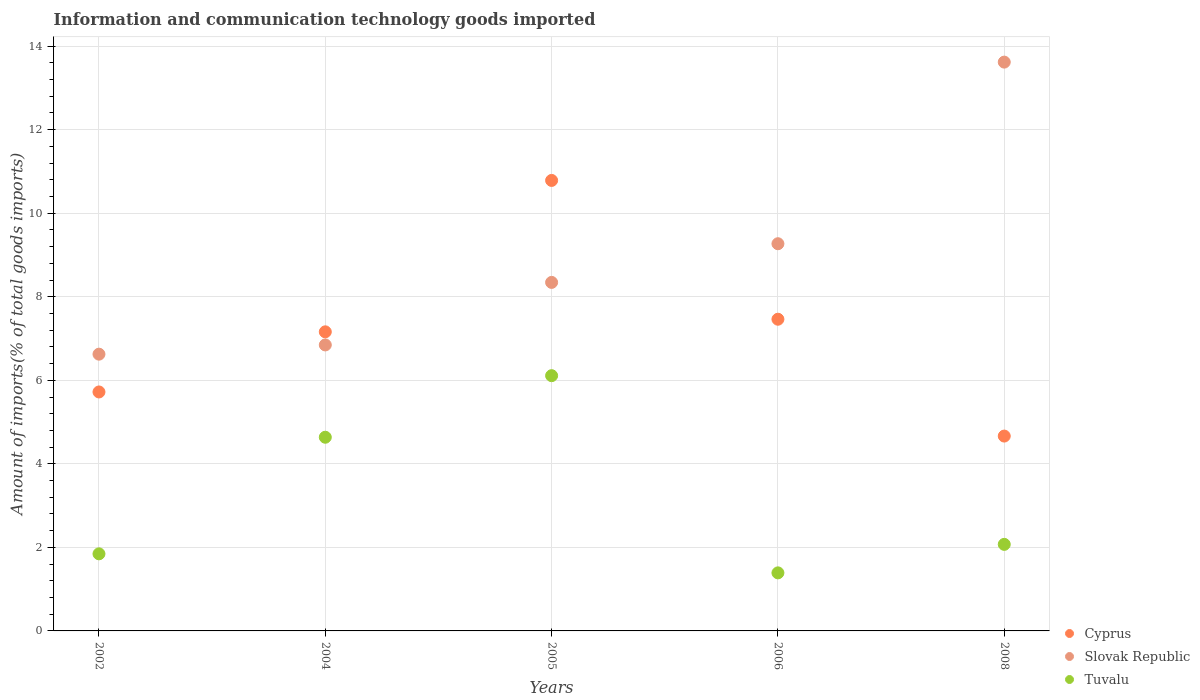How many different coloured dotlines are there?
Give a very brief answer. 3. Is the number of dotlines equal to the number of legend labels?
Keep it short and to the point. Yes. What is the amount of goods imported in Slovak Republic in 2004?
Offer a terse response. 6.85. Across all years, what is the maximum amount of goods imported in Cyprus?
Ensure brevity in your answer.  10.78. Across all years, what is the minimum amount of goods imported in Tuvalu?
Ensure brevity in your answer.  1.39. What is the total amount of goods imported in Cyprus in the graph?
Your answer should be compact. 35.79. What is the difference between the amount of goods imported in Tuvalu in 2005 and that in 2008?
Provide a succinct answer. 4.04. What is the difference between the amount of goods imported in Cyprus in 2005 and the amount of goods imported in Slovak Republic in 2008?
Offer a very short reply. -2.83. What is the average amount of goods imported in Slovak Republic per year?
Your answer should be compact. 8.94. In the year 2002, what is the difference between the amount of goods imported in Cyprus and amount of goods imported in Slovak Republic?
Offer a terse response. -0.9. In how many years, is the amount of goods imported in Tuvalu greater than 4 %?
Provide a short and direct response. 2. What is the ratio of the amount of goods imported in Tuvalu in 2002 to that in 2004?
Offer a terse response. 0.4. Is the difference between the amount of goods imported in Cyprus in 2004 and 2005 greater than the difference between the amount of goods imported in Slovak Republic in 2004 and 2005?
Keep it short and to the point. No. What is the difference between the highest and the second highest amount of goods imported in Tuvalu?
Provide a short and direct response. 1.47. What is the difference between the highest and the lowest amount of goods imported in Slovak Republic?
Your answer should be compact. 6.99. In how many years, is the amount of goods imported in Tuvalu greater than the average amount of goods imported in Tuvalu taken over all years?
Offer a very short reply. 2. Is it the case that in every year, the sum of the amount of goods imported in Cyprus and amount of goods imported in Tuvalu  is greater than the amount of goods imported in Slovak Republic?
Offer a terse response. No. Is the amount of goods imported in Slovak Republic strictly greater than the amount of goods imported in Tuvalu over the years?
Offer a terse response. Yes. Is the amount of goods imported in Cyprus strictly less than the amount of goods imported in Tuvalu over the years?
Ensure brevity in your answer.  No. How many dotlines are there?
Your answer should be very brief. 3. How many years are there in the graph?
Your answer should be compact. 5. What is the difference between two consecutive major ticks on the Y-axis?
Make the answer very short. 2. What is the title of the graph?
Provide a short and direct response. Information and communication technology goods imported. Does "Costa Rica" appear as one of the legend labels in the graph?
Give a very brief answer. No. What is the label or title of the Y-axis?
Keep it short and to the point. Amount of imports(% of total goods imports). What is the Amount of imports(% of total goods imports) of Cyprus in 2002?
Ensure brevity in your answer.  5.72. What is the Amount of imports(% of total goods imports) of Slovak Republic in 2002?
Give a very brief answer. 6.63. What is the Amount of imports(% of total goods imports) of Tuvalu in 2002?
Offer a terse response. 1.85. What is the Amount of imports(% of total goods imports) of Cyprus in 2004?
Give a very brief answer. 7.16. What is the Amount of imports(% of total goods imports) of Slovak Republic in 2004?
Offer a very short reply. 6.85. What is the Amount of imports(% of total goods imports) of Tuvalu in 2004?
Offer a terse response. 4.64. What is the Amount of imports(% of total goods imports) of Cyprus in 2005?
Your answer should be very brief. 10.78. What is the Amount of imports(% of total goods imports) in Slovak Republic in 2005?
Your answer should be very brief. 8.34. What is the Amount of imports(% of total goods imports) of Tuvalu in 2005?
Provide a short and direct response. 6.11. What is the Amount of imports(% of total goods imports) of Cyprus in 2006?
Your response must be concise. 7.46. What is the Amount of imports(% of total goods imports) in Slovak Republic in 2006?
Provide a short and direct response. 9.27. What is the Amount of imports(% of total goods imports) in Tuvalu in 2006?
Provide a short and direct response. 1.39. What is the Amount of imports(% of total goods imports) in Cyprus in 2008?
Make the answer very short. 4.66. What is the Amount of imports(% of total goods imports) of Slovak Republic in 2008?
Provide a succinct answer. 13.62. What is the Amount of imports(% of total goods imports) in Tuvalu in 2008?
Ensure brevity in your answer.  2.07. Across all years, what is the maximum Amount of imports(% of total goods imports) of Cyprus?
Offer a terse response. 10.78. Across all years, what is the maximum Amount of imports(% of total goods imports) in Slovak Republic?
Keep it short and to the point. 13.62. Across all years, what is the maximum Amount of imports(% of total goods imports) in Tuvalu?
Give a very brief answer. 6.11. Across all years, what is the minimum Amount of imports(% of total goods imports) in Cyprus?
Your response must be concise. 4.66. Across all years, what is the minimum Amount of imports(% of total goods imports) of Slovak Republic?
Ensure brevity in your answer.  6.63. Across all years, what is the minimum Amount of imports(% of total goods imports) in Tuvalu?
Your answer should be compact. 1.39. What is the total Amount of imports(% of total goods imports) of Cyprus in the graph?
Ensure brevity in your answer.  35.79. What is the total Amount of imports(% of total goods imports) of Slovak Republic in the graph?
Provide a succinct answer. 44.7. What is the total Amount of imports(% of total goods imports) of Tuvalu in the graph?
Offer a terse response. 16.05. What is the difference between the Amount of imports(% of total goods imports) of Cyprus in 2002 and that in 2004?
Your answer should be compact. -1.44. What is the difference between the Amount of imports(% of total goods imports) in Slovak Republic in 2002 and that in 2004?
Provide a succinct answer. -0.22. What is the difference between the Amount of imports(% of total goods imports) of Tuvalu in 2002 and that in 2004?
Your response must be concise. -2.79. What is the difference between the Amount of imports(% of total goods imports) in Cyprus in 2002 and that in 2005?
Give a very brief answer. -5.06. What is the difference between the Amount of imports(% of total goods imports) of Slovak Republic in 2002 and that in 2005?
Provide a short and direct response. -1.72. What is the difference between the Amount of imports(% of total goods imports) in Tuvalu in 2002 and that in 2005?
Provide a short and direct response. -4.26. What is the difference between the Amount of imports(% of total goods imports) of Cyprus in 2002 and that in 2006?
Provide a short and direct response. -1.74. What is the difference between the Amount of imports(% of total goods imports) in Slovak Republic in 2002 and that in 2006?
Your response must be concise. -2.64. What is the difference between the Amount of imports(% of total goods imports) of Tuvalu in 2002 and that in 2006?
Offer a terse response. 0.46. What is the difference between the Amount of imports(% of total goods imports) in Cyprus in 2002 and that in 2008?
Provide a short and direct response. 1.06. What is the difference between the Amount of imports(% of total goods imports) in Slovak Republic in 2002 and that in 2008?
Your response must be concise. -6.99. What is the difference between the Amount of imports(% of total goods imports) in Tuvalu in 2002 and that in 2008?
Offer a terse response. -0.23. What is the difference between the Amount of imports(% of total goods imports) of Cyprus in 2004 and that in 2005?
Provide a succinct answer. -3.62. What is the difference between the Amount of imports(% of total goods imports) in Slovak Republic in 2004 and that in 2005?
Make the answer very short. -1.5. What is the difference between the Amount of imports(% of total goods imports) in Tuvalu in 2004 and that in 2005?
Your response must be concise. -1.47. What is the difference between the Amount of imports(% of total goods imports) in Cyprus in 2004 and that in 2006?
Your answer should be compact. -0.3. What is the difference between the Amount of imports(% of total goods imports) in Slovak Republic in 2004 and that in 2006?
Your response must be concise. -2.42. What is the difference between the Amount of imports(% of total goods imports) in Tuvalu in 2004 and that in 2006?
Offer a very short reply. 3.25. What is the difference between the Amount of imports(% of total goods imports) of Cyprus in 2004 and that in 2008?
Your answer should be very brief. 2.5. What is the difference between the Amount of imports(% of total goods imports) in Slovak Republic in 2004 and that in 2008?
Your answer should be very brief. -6.77. What is the difference between the Amount of imports(% of total goods imports) in Tuvalu in 2004 and that in 2008?
Your answer should be very brief. 2.56. What is the difference between the Amount of imports(% of total goods imports) in Cyprus in 2005 and that in 2006?
Give a very brief answer. 3.32. What is the difference between the Amount of imports(% of total goods imports) in Slovak Republic in 2005 and that in 2006?
Offer a terse response. -0.93. What is the difference between the Amount of imports(% of total goods imports) of Tuvalu in 2005 and that in 2006?
Provide a short and direct response. 4.72. What is the difference between the Amount of imports(% of total goods imports) in Cyprus in 2005 and that in 2008?
Offer a very short reply. 6.12. What is the difference between the Amount of imports(% of total goods imports) in Slovak Republic in 2005 and that in 2008?
Your response must be concise. -5.27. What is the difference between the Amount of imports(% of total goods imports) in Tuvalu in 2005 and that in 2008?
Your response must be concise. 4.04. What is the difference between the Amount of imports(% of total goods imports) in Cyprus in 2006 and that in 2008?
Your answer should be very brief. 2.8. What is the difference between the Amount of imports(% of total goods imports) of Slovak Republic in 2006 and that in 2008?
Offer a terse response. -4.35. What is the difference between the Amount of imports(% of total goods imports) of Tuvalu in 2006 and that in 2008?
Provide a short and direct response. -0.68. What is the difference between the Amount of imports(% of total goods imports) in Cyprus in 2002 and the Amount of imports(% of total goods imports) in Slovak Republic in 2004?
Make the answer very short. -1.13. What is the difference between the Amount of imports(% of total goods imports) in Cyprus in 2002 and the Amount of imports(% of total goods imports) in Tuvalu in 2004?
Provide a short and direct response. 1.08. What is the difference between the Amount of imports(% of total goods imports) in Slovak Republic in 2002 and the Amount of imports(% of total goods imports) in Tuvalu in 2004?
Provide a succinct answer. 1.99. What is the difference between the Amount of imports(% of total goods imports) in Cyprus in 2002 and the Amount of imports(% of total goods imports) in Slovak Republic in 2005?
Your response must be concise. -2.62. What is the difference between the Amount of imports(% of total goods imports) in Cyprus in 2002 and the Amount of imports(% of total goods imports) in Tuvalu in 2005?
Your answer should be compact. -0.39. What is the difference between the Amount of imports(% of total goods imports) of Slovak Republic in 2002 and the Amount of imports(% of total goods imports) of Tuvalu in 2005?
Offer a terse response. 0.51. What is the difference between the Amount of imports(% of total goods imports) in Cyprus in 2002 and the Amount of imports(% of total goods imports) in Slovak Republic in 2006?
Give a very brief answer. -3.55. What is the difference between the Amount of imports(% of total goods imports) of Cyprus in 2002 and the Amount of imports(% of total goods imports) of Tuvalu in 2006?
Your answer should be very brief. 4.33. What is the difference between the Amount of imports(% of total goods imports) in Slovak Republic in 2002 and the Amount of imports(% of total goods imports) in Tuvalu in 2006?
Provide a short and direct response. 5.24. What is the difference between the Amount of imports(% of total goods imports) of Cyprus in 2002 and the Amount of imports(% of total goods imports) of Slovak Republic in 2008?
Offer a very short reply. -7.9. What is the difference between the Amount of imports(% of total goods imports) in Cyprus in 2002 and the Amount of imports(% of total goods imports) in Tuvalu in 2008?
Your answer should be compact. 3.65. What is the difference between the Amount of imports(% of total goods imports) of Slovak Republic in 2002 and the Amount of imports(% of total goods imports) of Tuvalu in 2008?
Provide a succinct answer. 4.55. What is the difference between the Amount of imports(% of total goods imports) of Cyprus in 2004 and the Amount of imports(% of total goods imports) of Slovak Republic in 2005?
Offer a very short reply. -1.18. What is the difference between the Amount of imports(% of total goods imports) of Cyprus in 2004 and the Amount of imports(% of total goods imports) of Tuvalu in 2005?
Give a very brief answer. 1.05. What is the difference between the Amount of imports(% of total goods imports) in Slovak Republic in 2004 and the Amount of imports(% of total goods imports) in Tuvalu in 2005?
Your answer should be compact. 0.74. What is the difference between the Amount of imports(% of total goods imports) in Cyprus in 2004 and the Amount of imports(% of total goods imports) in Slovak Republic in 2006?
Keep it short and to the point. -2.11. What is the difference between the Amount of imports(% of total goods imports) of Cyprus in 2004 and the Amount of imports(% of total goods imports) of Tuvalu in 2006?
Ensure brevity in your answer.  5.77. What is the difference between the Amount of imports(% of total goods imports) of Slovak Republic in 2004 and the Amount of imports(% of total goods imports) of Tuvalu in 2006?
Your answer should be compact. 5.46. What is the difference between the Amount of imports(% of total goods imports) in Cyprus in 2004 and the Amount of imports(% of total goods imports) in Slovak Republic in 2008?
Make the answer very short. -6.46. What is the difference between the Amount of imports(% of total goods imports) in Cyprus in 2004 and the Amount of imports(% of total goods imports) in Tuvalu in 2008?
Keep it short and to the point. 5.09. What is the difference between the Amount of imports(% of total goods imports) in Slovak Republic in 2004 and the Amount of imports(% of total goods imports) in Tuvalu in 2008?
Offer a terse response. 4.77. What is the difference between the Amount of imports(% of total goods imports) in Cyprus in 2005 and the Amount of imports(% of total goods imports) in Slovak Republic in 2006?
Your answer should be very brief. 1.52. What is the difference between the Amount of imports(% of total goods imports) of Cyprus in 2005 and the Amount of imports(% of total goods imports) of Tuvalu in 2006?
Give a very brief answer. 9.39. What is the difference between the Amount of imports(% of total goods imports) in Slovak Republic in 2005 and the Amount of imports(% of total goods imports) in Tuvalu in 2006?
Keep it short and to the point. 6.95. What is the difference between the Amount of imports(% of total goods imports) in Cyprus in 2005 and the Amount of imports(% of total goods imports) in Slovak Republic in 2008?
Your answer should be very brief. -2.83. What is the difference between the Amount of imports(% of total goods imports) of Cyprus in 2005 and the Amount of imports(% of total goods imports) of Tuvalu in 2008?
Provide a short and direct response. 8.71. What is the difference between the Amount of imports(% of total goods imports) in Slovak Republic in 2005 and the Amount of imports(% of total goods imports) in Tuvalu in 2008?
Your answer should be very brief. 6.27. What is the difference between the Amount of imports(% of total goods imports) of Cyprus in 2006 and the Amount of imports(% of total goods imports) of Slovak Republic in 2008?
Make the answer very short. -6.16. What is the difference between the Amount of imports(% of total goods imports) of Cyprus in 2006 and the Amount of imports(% of total goods imports) of Tuvalu in 2008?
Provide a succinct answer. 5.39. What is the difference between the Amount of imports(% of total goods imports) in Slovak Republic in 2006 and the Amount of imports(% of total goods imports) in Tuvalu in 2008?
Keep it short and to the point. 7.2. What is the average Amount of imports(% of total goods imports) of Cyprus per year?
Provide a short and direct response. 7.16. What is the average Amount of imports(% of total goods imports) in Slovak Republic per year?
Make the answer very short. 8.94. What is the average Amount of imports(% of total goods imports) in Tuvalu per year?
Offer a very short reply. 3.21. In the year 2002, what is the difference between the Amount of imports(% of total goods imports) in Cyprus and Amount of imports(% of total goods imports) in Slovak Republic?
Ensure brevity in your answer.  -0.9. In the year 2002, what is the difference between the Amount of imports(% of total goods imports) of Cyprus and Amount of imports(% of total goods imports) of Tuvalu?
Provide a succinct answer. 3.88. In the year 2002, what is the difference between the Amount of imports(% of total goods imports) of Slovak Republic and Amount of imports(% of total goods imports) of Tuvalu?
Keep it short and to the point. 4.78. In the year 2004, what is the difference between the Amount of imports(% of total goods imports) of Cyprus and Amount of imports(% of total goods imports) of Slovak Republic?
Provide a short and direct response. 0.31. In the year 2004, what is the difference between the Amount of imports(% of total goods imports) in Cyprus and Amount of imports(% of total goods imports) in Tuvalu?
Your answer should be very brief. 2.52. In the year 2004, what is the difference between the Amount of imports(% of total goods imports) in Slovak Republic and Amount of imports(% of total goods imports) in Tuvalu?
Keep it short and to the point. 2.21. In the year 2005, what is the difference between the Amount of imports(% of total goods imports) in Cyprus and Amount of imports(% of total goods imports) in Slovak Republic?
Your answer should be compact. 2.44. In the year 2005, what is the difference between the Amount of imports(% of total goods imports) in Cyprus and Amount of imports(% of total goods imports) in Tuvalu?
Offer a very short reply. 4.67. In the year 2005, what is the difference between the Amount of imports(% of total goods imports) in Slovak Republic and Amount of imports(% of total goods imports) in Tuvalu?
Offer a terse response. 2.23. In the year 2006, what is the difference between the Amount of imports(% of total goods imports) in Cyprus and Amount of imports(% of total goods imports) in Slovak Republic?
Provide a short and direct response. -1.81. In the year 2006, what is the difference between the Amount of imports(% of total goods imports) of Cyprus and Amount of imports(% of total goods imports) of Tuvalu?
Give a very brief answer. 6.07. In the year 2006, what is the difference between the Amount of imports(% of total goods imports) in Slovak Republic and Amount of imports(% of total goods imports) in Tuvalu?
Ensure brevity in your answer.  7.88. In the year 2008, what is the difference between the Amount of imports(% of total goods imports) of Cyprus and Amount of imports(% of total goods imports) of Slovak Republic?
Provide a succinct answer. -8.95. In the year 2008, what is the difference between the Amount of imports(% of total goods imports) of Cyprus and Amount of imports(% of total goods imports) of Tuvalu?
Keep it short and to the point. 2.59. In the year 2008, what is the difference between the Amount of imports(% of total goods imports) in Slovak Republic and Amount of imports(% of total goods imports) in Tuvalu?
Keep it short and to the point. 11.55. What is the ratio of the Amount of imports(% of total goods imports) of Cyprus in 2002 to that in 2004?
Your answer should be compact. 0.8. What is the ratio of the Amount of imports(% of total goods imports) in Slovak Republic in 2002 to that in 2004?
Provide a short and direct response. 0.97. What is the ratio of the Amount of imports(% of total goods imports) in Tuvalu in 2002 to that in 2004?
Ensure brevity in your answer.  0.4. What is the ratio of the Amount of imports(% of total goods imports) in Cyprus in 2002 to that in 2005?
Offer a terse response. 0.53. What is the ratio of the Amount of imports(% of total goods imports) in Slovak Republic in 2002 to that in 2005?
Offer a very short reply. 0.79. What is the ratio of the Amount of imports(% of total goods imports) of Tuvalu in 2002 to that in 2005?
Make the answer very short. 0.3. What is the ratio of the Amount of imports(% of total goods imports) of Cyprus in 2002 to that in 2006?
Provide a succinct answer. 0.77. What is the ratio of the Amount of imports(% of total goods imports) in Slovak Republic in 2002 to that in 2006?
Provide a short and direct response. 0.71. What is the ratio of the Amount of imports(% of total goods imports) of Tuvalu in 2002 to that in 2006?
Your answer should be very brief. 1.33. What is the ratio of the Amount of imports(% of total goods imports) in Cyprus in 2002 to that in 2008?
Your response must be concise. 1.23. What is the ratio of the Amount of imports(% of total goods imports) of Slovak Republic in 2002 to that in 2008?
Your answer should be very brief. 0.49. What is the ratio of the Amount of imports(% of total goods imports) of Tuvalu in 2002 to that in 2008?
Provide a succinct answer. 0.89. What is the ratio of the Amount of imports(% of total goods imports) in Cyprus in 2004 to that in 2005?
Your answer should be very brief. 0.66. What is the ratio of the Amount of imports(% of total goods imports) in Slovak Republic in 2004 to that in 2005?
Offer a very short reply. 0.82. What is the ratio of the Amount of imports(% of total goods imports) of Tuvalu in 2004 to that in 2005?
Keep it short and to the point. 0.76. What is the ratio of the Amount of imports(% of total goods imports) in Cyprus in 2004 to that in 2006?
Your response must be concise. 0.96. What is the ratio of the Amount of imports(% of total goods imports) of Slovak Republic in 2004 to that in 2006?
Make the answer very short. 0.74. What is the ratio of the Amount of imports(% of total goods imports) of Tuvalu in 2004 to that in 2006?
Offer a terse response. 3.34. What is the ratio of the Amount of imports(% of total goods imports) in Cyprus in 2004 to that in 2008?
Provide a succinct answer. 1.53. What is the ratio of the Amount of imports(% of total goods imports) of Slovak Republic in 2004 to that in 2008?
Offer a terse response. 0.5. What is the ratio of the Amount of imports(% of total goods imports) of Tuvalu in 2004 to that in 2008?
Your response must be concise. 2.24. What is the ratio of the Amount of imports(% of total goods imports) in Cyprus in 2005 to that in 2006?
Provide a succinct answer. 1.45. What is the ratio of the Amount of imports(% of total goods imports) of Slovak Republic in 2005 to that in 2006?
Offer a very short reply. 0.9. What is the ratio of the Amount of imports(% of total goods imports) of Tuvalu in 2005 to that in 2006?
Your answer should be very brief. 4.4. What is the ratio of the Amount of imports(% of total goods imports) of Cyprus in 2005 to that in 2008?
Keep it short and to the point. 2.31. What is the ratio of the Amount of imports(% of total goods imports) of Slovak Republic in 2005 to that in 2008?
Offer a very short reply. 0.61. What is the ratio of the Amount of imports(% of total goods imports) in Tuvalu in 2005 to that in 2008?
Provide a succinct answer. 2.95. What is the ratio of the Amount of imports(% of total goods imports) of Cyprus in 2006 to that in 2008?
Offer a terse response. 1.6. What is the ratio of the Amount of imports(% of total goods imports) of Slovak Republic in 2006 to that in 2008?
Provide a succinct answer. 0.68. What is the ratio of the Amount of imports(% of total goods imports) in Tuvalu in 2006 to that in 2008?
Give a very brief answer. 0.67. What is the difference between the highest and the second highest Amount of imports(% of total goods imports) in Cyprus?
Give a very brief answer. 3.32. What is the difference between the highest and the second highest Amount of imports(% of total goods imports) of Slovak Republic?
Your answer should be compact. 4.35. What is the difference between the highest and the second highest Amount of imports(% of total goods imports) of Tuvalu?
Provide a short and direct response. 1.47. What is the difference between the highest and the lowest Amount of imports(% of total goods imports) in Cyprus?
Provide a succinct answer. 6.12. What is the difference between the highest and the lowest Amount of imports(% of total goods imports) in Slovak Republic?
Keep it short and to the point. 6.99. What is the difference between the highest and the lowest Amount of imports(% of total goods imports) of Tuvalu?
Ensure brevity in your answer.  4.72. 